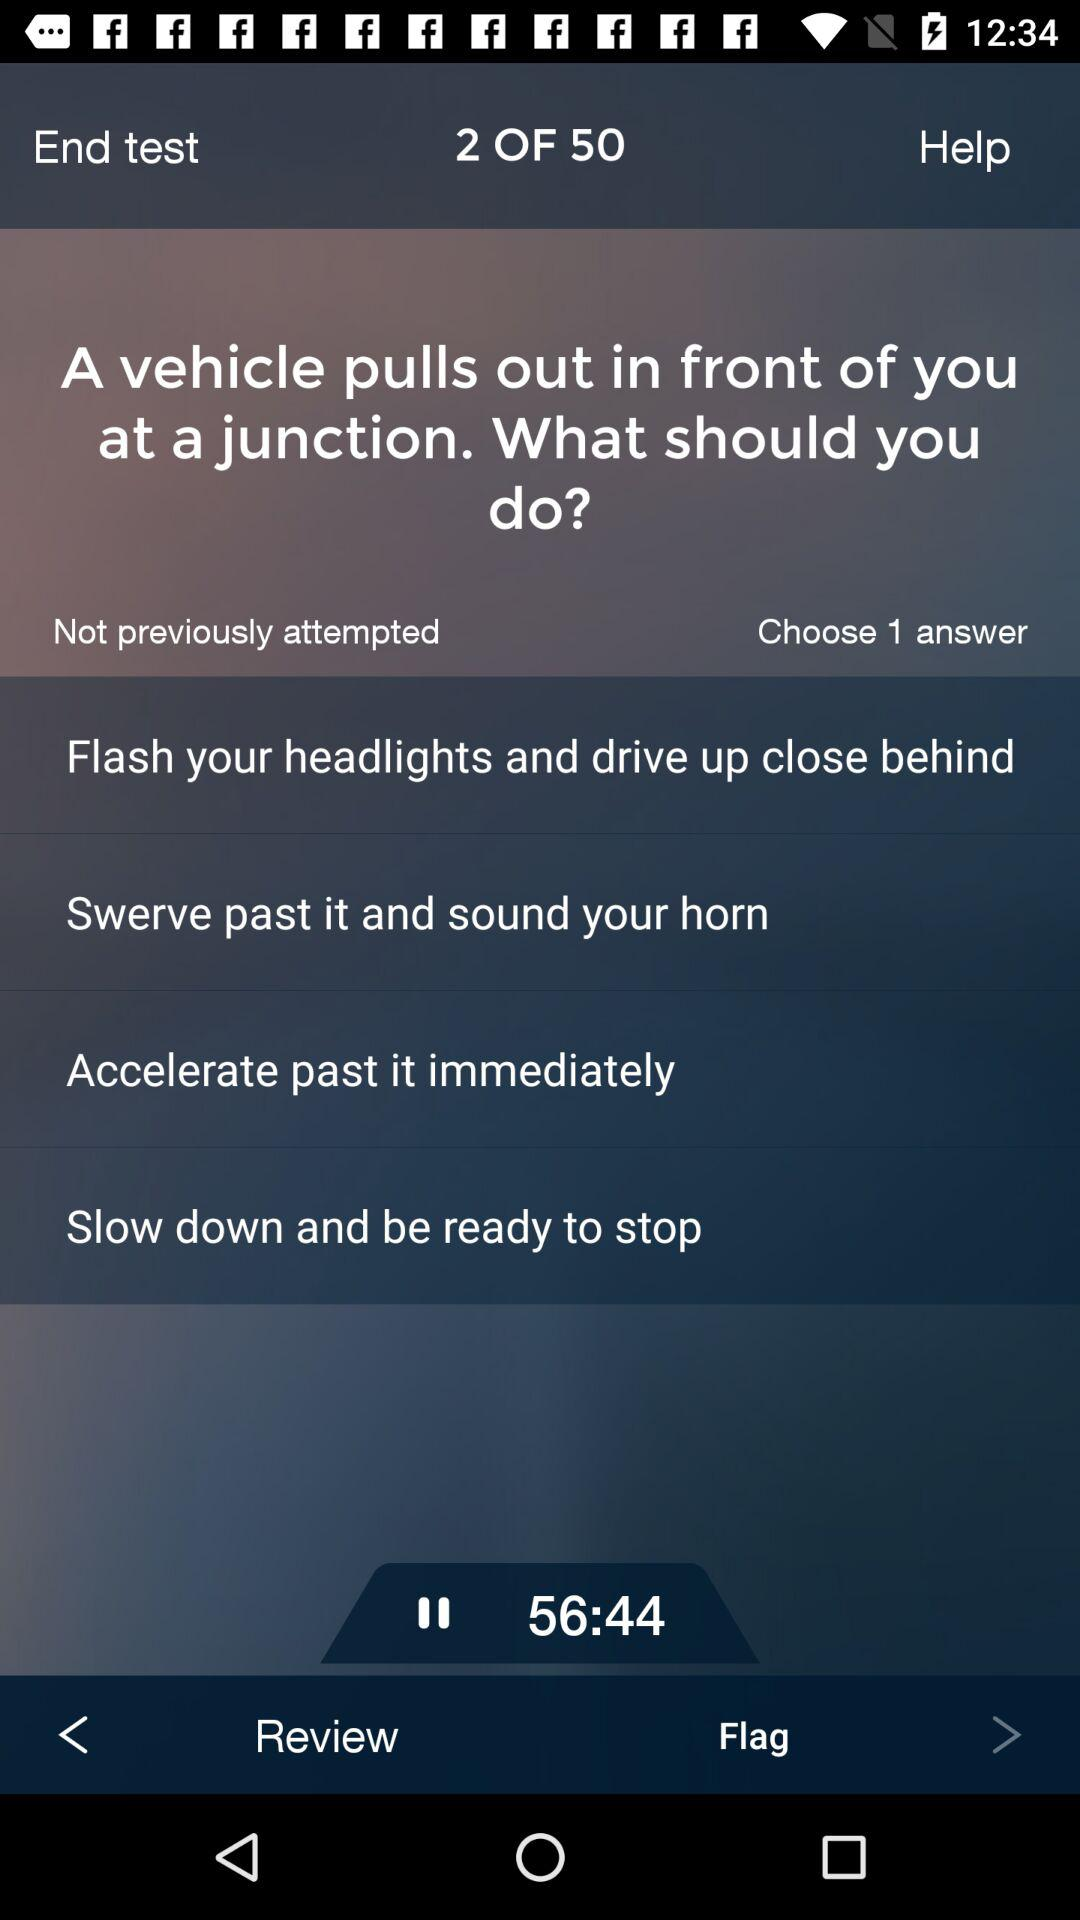What is the displayed duration? The displayed duration is 56 minutes and 44 seconds. 